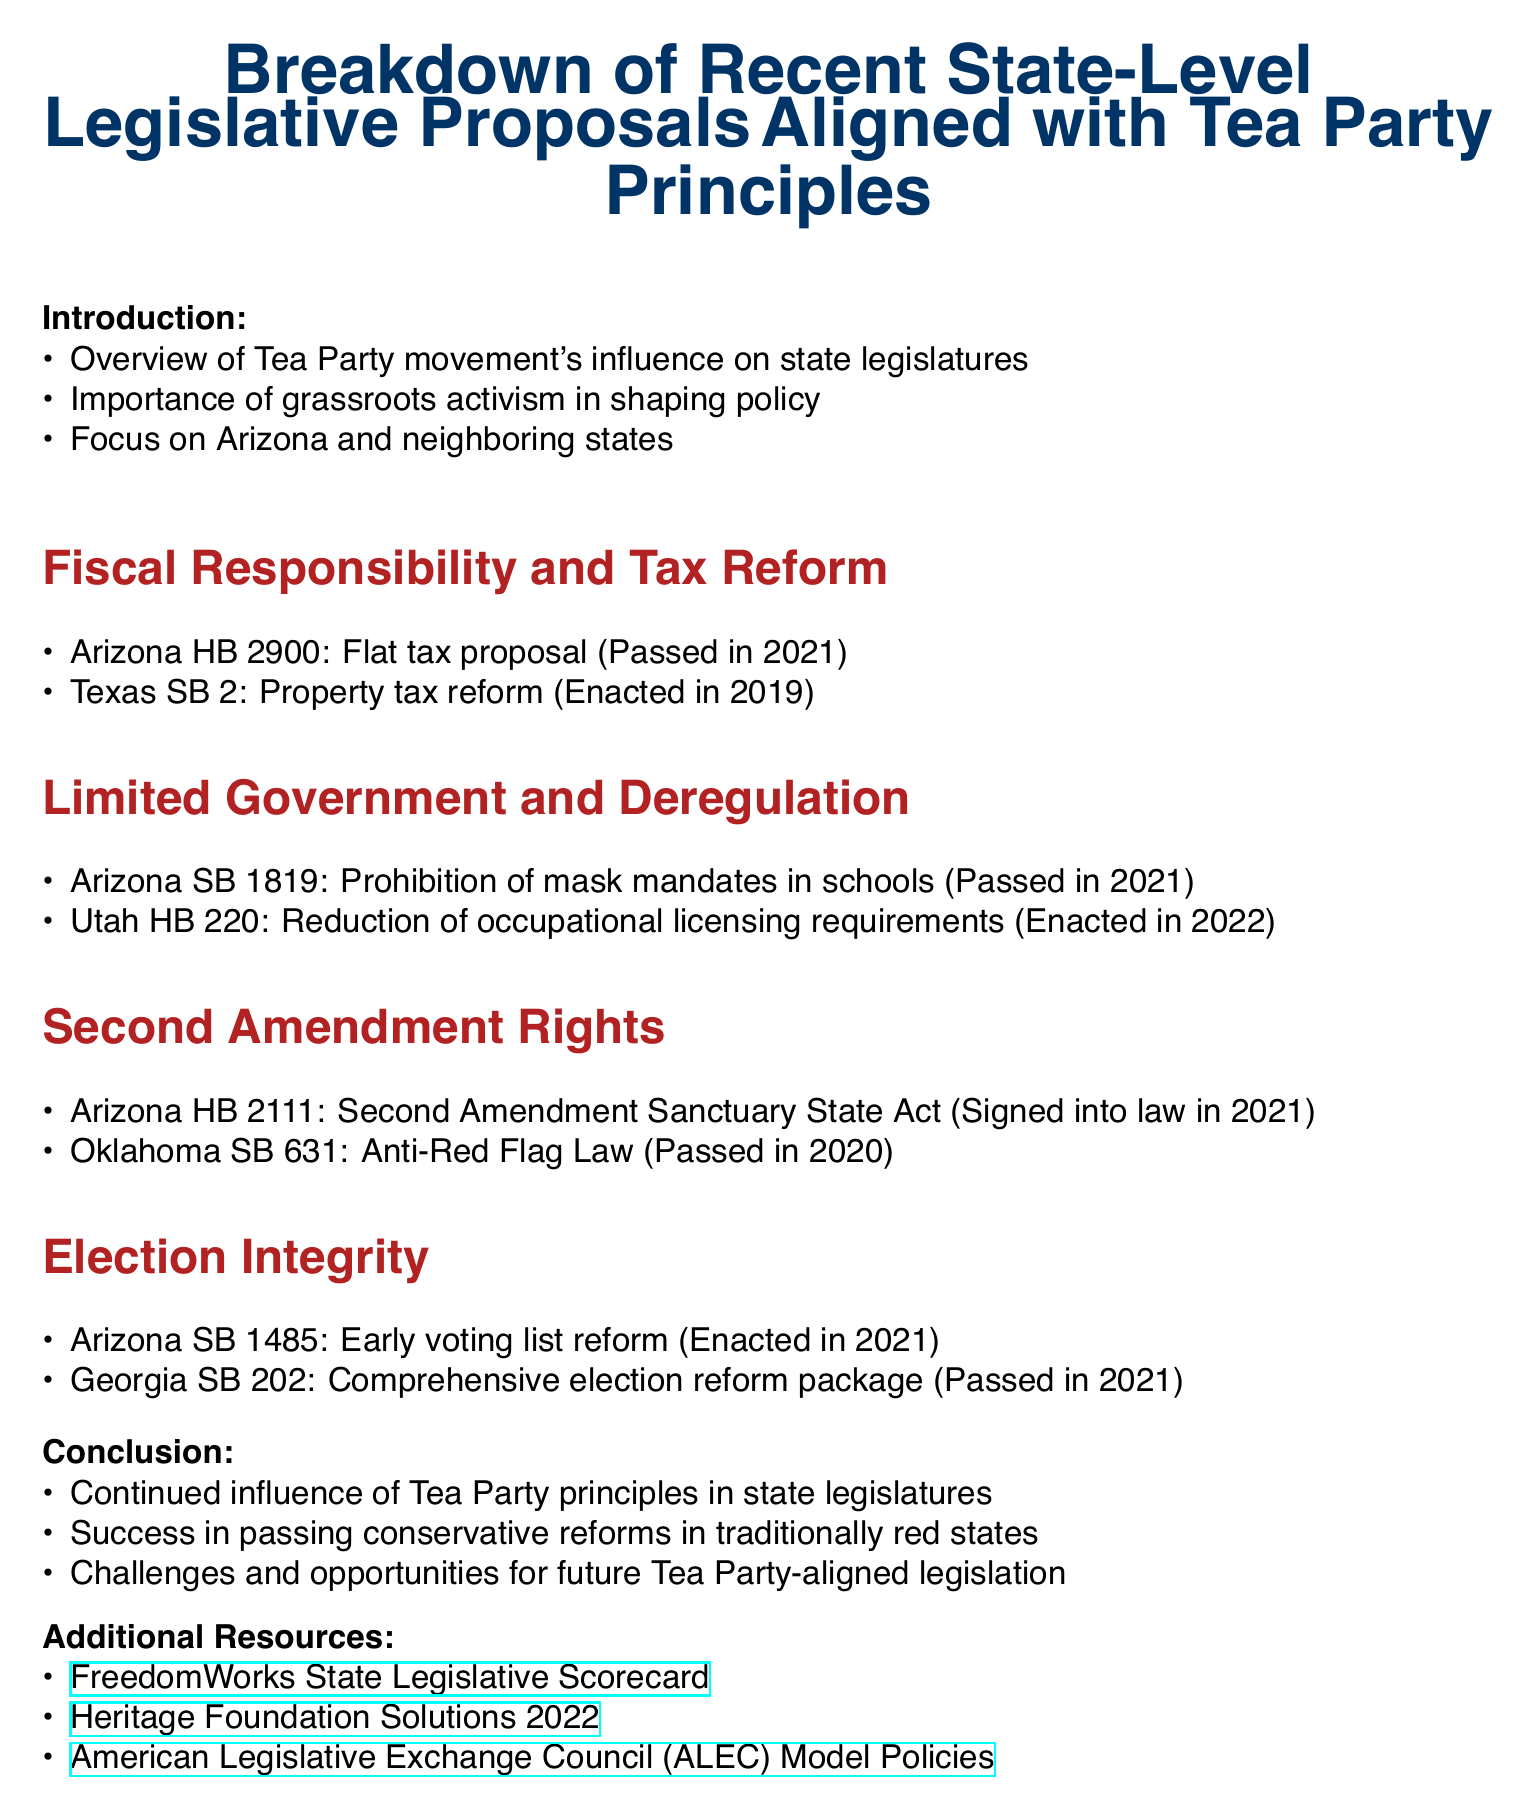What is the title of the agenda? The title of the agenda is found at the very beginning and indicates the main focus of the document.
Answer: Breakdown of Recent State-Level Legislative Proposals Aligned with Tea Party Principles Which state proposed the flat tax bill? The flat tax proposal is specifically mentioned along with its associated state in the document.
Answer: Arizona Who sponsored the Second Amendment Sanctuary State Act? The document lists the sponsors of various bills, including this specific act.
Answer: Rep. Leo Biasiucci What year was the property tax reform enacted in Texas? The enactment date for the tax reform can be found within the context of Texas legislative proposals.
Answer: 2019 What is the status of the early voting list reform in Arizona? The status indicates whether the proposal was passed, enacted, or signed into law according to the document.
Answer: Enacted in 2021 How many main sections are there in the document? The total number of main sections can be counted from the document's structure.
Answer: Four What principle does SB 1819 align with? The proposal is categorized under specific principles that the Tea Party supports, which can be found in the section titles.
Answer: Limited Government and Deregulation What is the main takeaway regarding Tea Party influence? The document summarizes key takeaways towards the end, highlighting the influence's impact on legislation.
Answer: Continued influence of Tea Party principles in state legislatures What organization provides a state legislative scorecard as a resource? The document lists additional resources, which include organizations related to the Tea Party and their legislative efforts.
Answer: FreedomWorks 